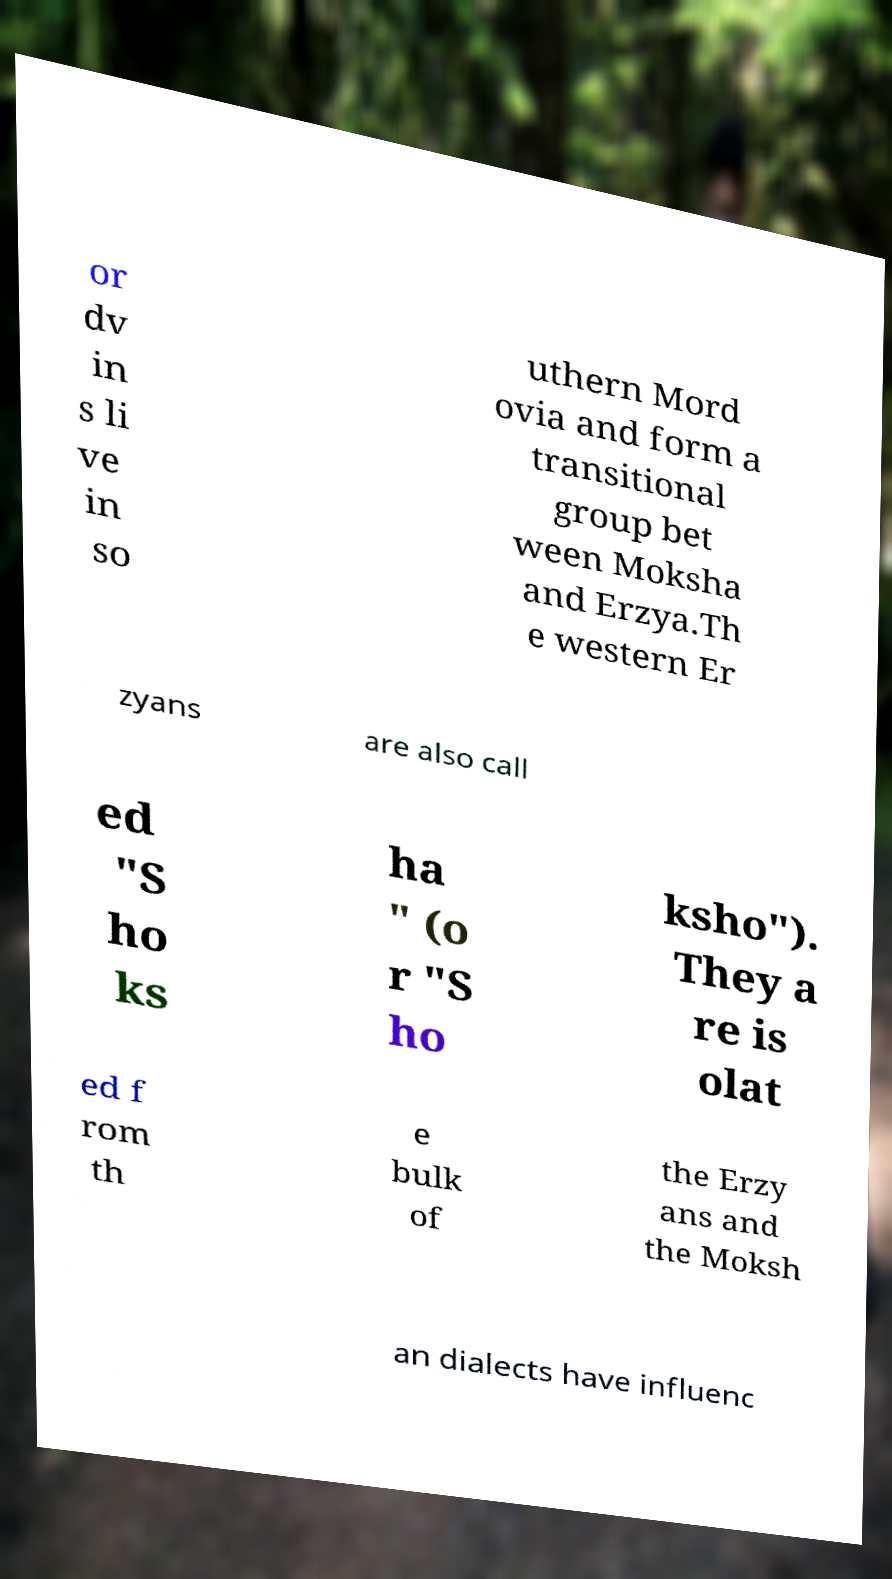Can you read and provide the text displayed in the image?This photo seems to have some interesting text. Can you extract and type it out for me? or dv in s li ve in so uthern Mord ovia and form a transitional group bet ween Moksha and Erzya.Th e western Er zyans are also call ed "S ho ks ha " (o r "S ho ksho"). They a re is olat ed f rom th e bulk of the Erzy ans and the Moksh an dialects have influenc 